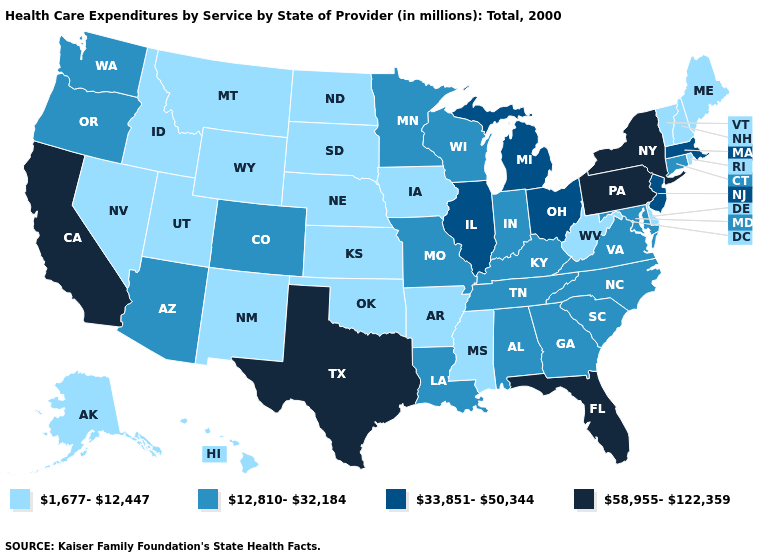Name the states that have a value in the range 33,851-50,344?
Be succinct. Illinois, Massachusetts, Michigan, New Jersey, Ohio. What is the value of Minnesota?
Concise answer only. 12,810-32,184. Name the states that have a value in the range 33,851-50,344?
Concise answer only. Illinois, Massachusetts, Michigan, New Jersey, Ohio. Name the states that have a value in the range 1,677-12,447?
Be succinct. Alaska, Arkansas, Delaware, Hawaii, Idaho, Iowa, Kansas, Maine, Mississippi, Montana, Nebraska, Nevada, New Hampshire, New Mexico, North Dakota, Oklahoma, Rhode Island, South Dakota, Utah, Vermont, West Virginia, Wyoming. Does West Virginia have a lower value than South Carolina?
Quick response, please. Yes. Is the legend a continuous bar?
Concise answer only. No. What is the value of California?
Concise answer only. 58,955-122,359. Does the first symbol in the legend represent the smallest category?
Short answer required. Yes. What is the value of West Virginia?
Write a very short answer. 1,677-12,447. What is the value of North Dakota?
Give a very brief answer. 1,677-12,447. What is the value of Arkansas?
Give a very brief answer. 1,677-12,447. Which states hav the highest value in the Northeast?
Write a very short answer. New York, Pennsylvania. What is the highest value in the USA?
Quick response, please. 58,955-122,359. Does the first symbol in the legend represent the smallest category?
Quick response, please. Yes. How many symbols are there in the legend?
Keep it brief. 4. 